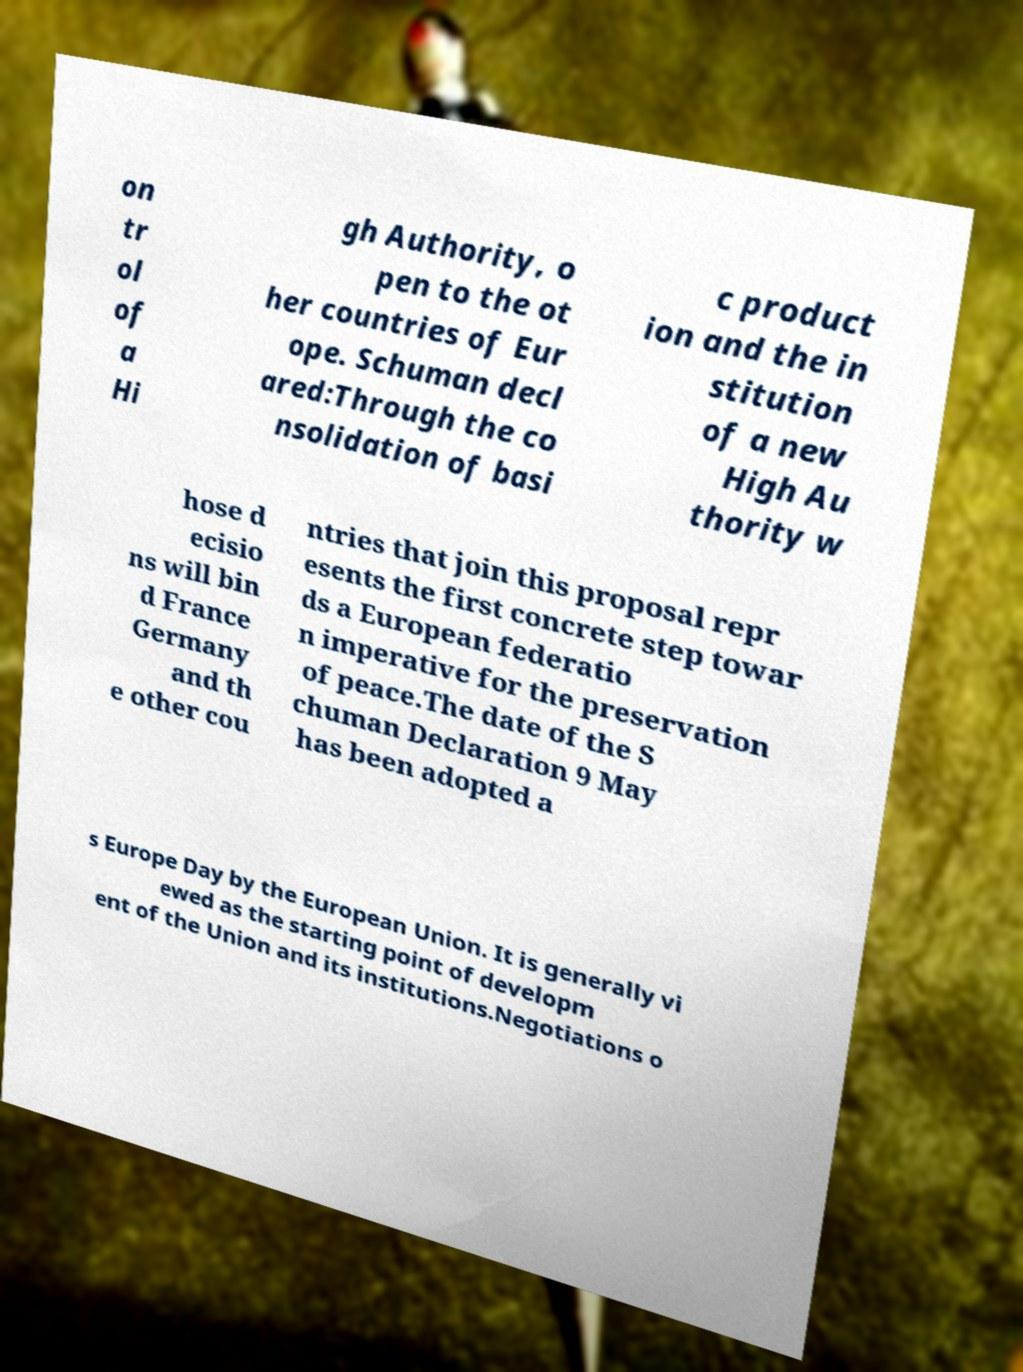Please identify and transcribe the text found in this image. on tr ol of a Hi gh Authority, o pen to the ot her countries of Eur ope. Schuman decl ared:Through the co nsolidation of basi c product ion and the in stitution of a new High Au thority w hose d ecisio ns will bin d France Germany and th e other cou ntries that join this proposal repr esents the first concrete step towar ds a European federatio n imperative for the preservation of peace.The date of the S chuman Declaration 9 May has been adopted a s Europe Day by the European Union. It is generally vi ewed as the starting point of developm ent of the Union and its institutions.Negotiations o 